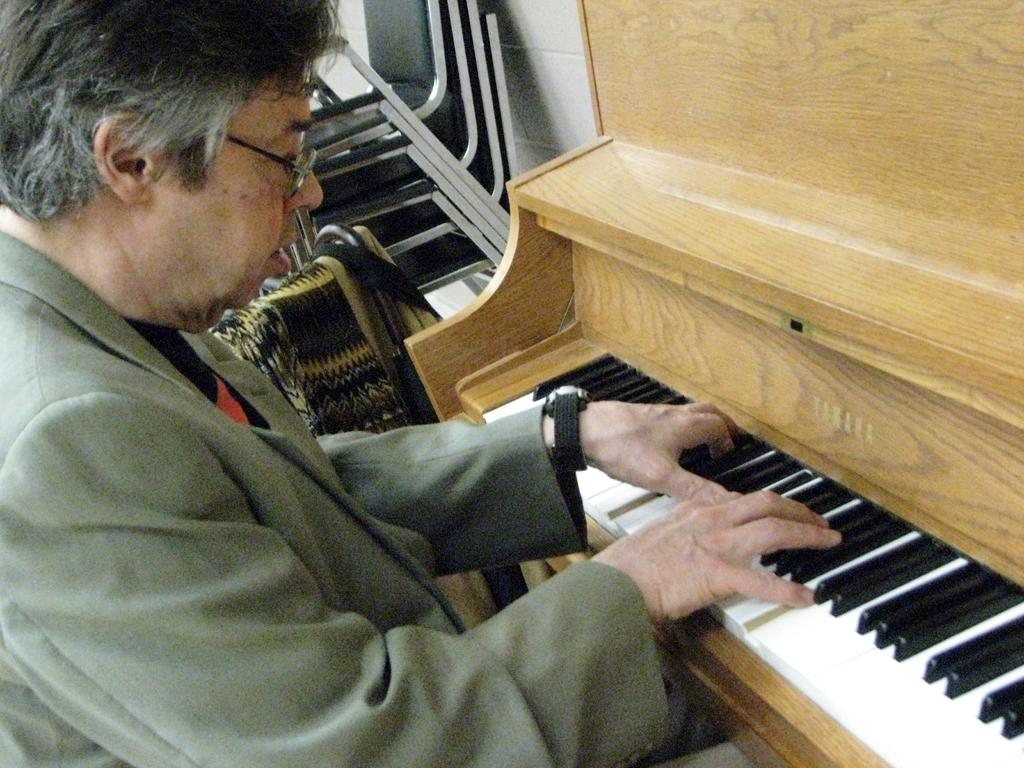Who is present in the image? There is a person in the image. What is the person wearing? The person is wearing a suit. What is the person doing in the image? The person is playing a musical instrument. What type of animal can be seen playing with a vase in the image? There is no animal or vase present in the image; it features a person wearing a suit and playing a musical instrument. 